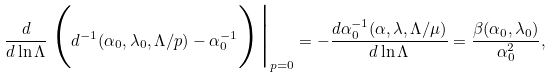Convert formula to latex. <formula><loc_0><loc_0><loc_500><loc_500>\frac { d } { d \ln \Lambda } \, \Big ( d ^ { - 1 } ( \alpha _ { 0 } , \lambda _ { 0 } , \Lambda / p ) - \alpha _ { 0 } ^ { - 1 } \Big ) \Big | _ { p = 0 } = - \frac { d \alpha _ { 0 } ^ { - 1 } ( \alpha , \lambda , \Lambda / \mu ) } { d \ln \Lambda } = \frac { \beta ( \alpha _ { 0 } , \lambda _ { 0 } ) } { \alpha _ { 0 } ^ { 2 } } ,</formula> 